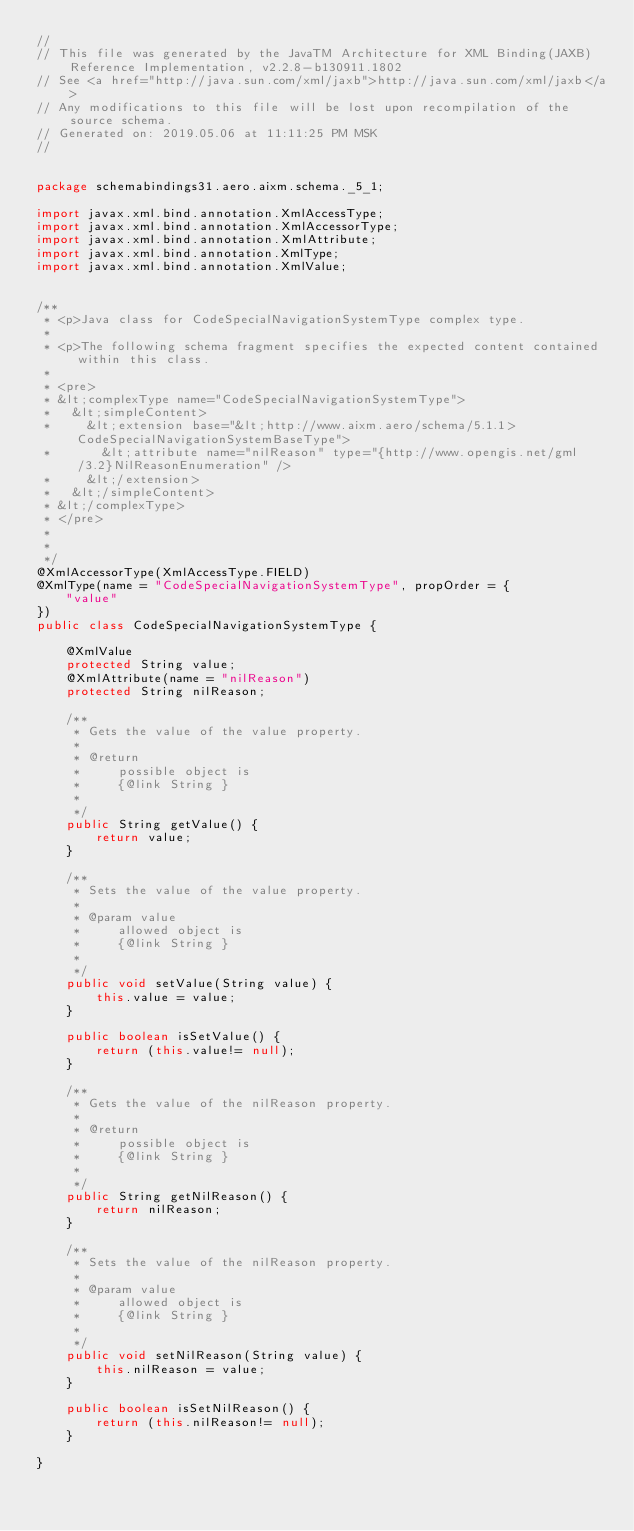<code> <loc_0><loc_0><loc_500><loc_500><_Java_>//
// This file was generated by the JavaTM Architecture for XML Binding(JAXB) Reference Implementation, v2.2.8-b130911.1802 
// See <a href="http://java.sun.com/xml/jaxb">http://java.sun.com/xml/jaxb</a> 
// Any modifications to this file will be lost upon recompilation of the source schema. 
// Generated on: 2019.05.06 at 11:11:25 PM MSK 
//


package schemabindings31.aero.aixm.schema._5_1;

import javax.xml.bind.annotation.XmlAccessType;
import javax.xml.bind.annotation.XmlAccessorType;
import javax.xml.bind.annotation.XmlAttribute;
import javax.xml.bind.annotation.XmlType;
import javax.xml.bind.annotation.XmlValue;


/**
 * <p>Java class for CodeSpecialNavigationSystemType complex type.
 * 
 * <p>The following schema fragment specifies the expected content contained within this class.
 * 
 * <pre>
 * &lt;complexType name="CodeSpecialNavigationSystemType">
 *   &lt;simpleContent>
 *     &lt;extension base="&lt;http://www.aixm.aero/schema/5.1.1>CodeSpecialNavigationSystemBaseType">
 *       &lt;attribute name="nilReason" type="{http://www.opengis.net/gml/3.2}NilReasonEnumeration" />
 *     &lt;/extension>
 *   &lt;/simpleContent>
 * &lt;/complexType>
 * </pre>
 * 
 * 
 */
@XmlAccessorType(XmlAccessType.FIELD)
@XmlType(name = "CodeSpecialNavigationSystemType", propOrder = {
    "value"
})
public class CodeSpecialNavigationSystemType {

    @XmlValue
    protected String value;
    @XmlAttribute(name = "nilReason")
    protected String nilReason;

    /**
     * Gets the value of the value property.
     * 
     * @return
     *     possible object is
     *     {@link String }
     *     
     */
    public String getValue() {
        return value;
    }

    /**
     * Sets the value of the value property.
     * 
     * @param value
     *     allowed object is
     *     {@link String }
     *     
     */
    public void setValue(String value) {
        this.value = value;
    }

    public boolean isSetValue() {
        return (this.value!= null);
    }

    /**
     * Gets the value of the nilReason property.
     * 
     * @return
     *     possible object is
     *     {@link String }
     *     
     */
    public String getNilReason() {
        return nilReason;
    }

    /**
     * Sets the value of the nilReason property.
     * 
     * @param value
     *     allowed object is
     *     {@link String }
     *     
     */
    public void setNilReason(String value) {
        this.nilReason = value;
    }

    public boolean isSetNilReason() {
        return (this.nilReason!= null);
    }

}
</code> 